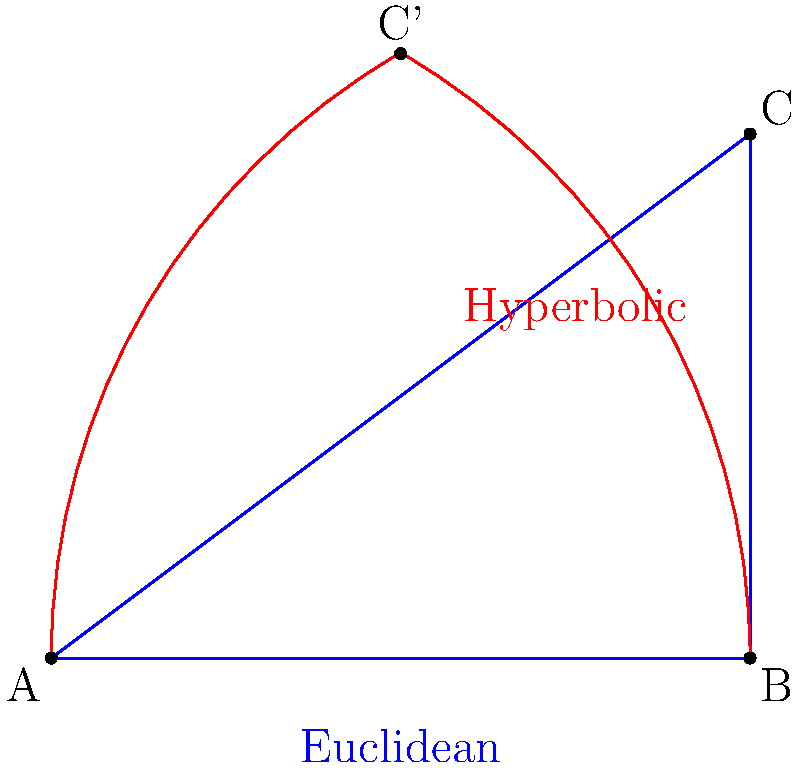In the diagram above, two triangles are shown: a blue Euclidean triangle ABC and a red hyperbolic triangle ABC'. If the side lengths of the hyperbolic triangle are equivalent to those of the Euclidean triangle, how does the area of the hyperbolic triangle compare to the area of the Euclidean triangle? Relate this to the concept of "defect" in hyperbolic geometry, drawing an analogy to the financial concept of opportunity cost. To answer this question, let's break it down step-by-step:

1. Euclidean Triangle:
   In Euclidean geometry, the Pythagorean theorem states that $a^2 + b^2 = c^2$ for a right triangle.
   The area of the Euclidean triangle ABC is given by $A_E = \frac{1}{2}bh = \frac{1}{2}(4)(3) = 6$ square units.

2. Hyperbolic Triangle:
   In hyperbolic geometry, the Pythagorean theorem is modified. For a right triangle, we have:
   $\cosh(c) = \cosh(a)\cosh(b)$, where $\cosh$ is the hyperbolic cosine function.

3. Area Comparison:
   In hyperbolic geometry, the sum of the angles of a triangle is always less than 180°. This difference from 180° is called the "defect."
   The area of a hyperbolic triangle is directly proportional to its defect: $A_H = k(α + β + γ - π)$, where k is a constant and α, β, γ are the angles.

4. Defect and Area:
   Since the sum of angles in a hyperbolic triangle is less than 180°, the area of the hyperbolic triangle ABC' is always smaller than its Euclidean counterpart ABC, even when the side lengths are the same.

5. Financial Analogy:
   The concept of "defect" in hyperbolic geometry can be likened to opportunity cost in finance. Just as the defect represents a "loss" of angle measure compared to Euclidean geometry, opportunity cost represents the potential gain from alternative choices when one particular choice is made.

6. 49ers Connection:
   Think of the hyperbolic triangle as a conservative financial strategy (like a strong defense in football), while the Euclidean triangle represents a more aggressive approach (like the 49ers' dynamic offense). The difference in areas (defect) represents the trade-off between risk and potential return, similar to how the 49ers balance their offensive and defensive strategies.
Answer: The hyperbolic triangle has a smaller area due to angular defect, analogous to opportunity cost in finance. 